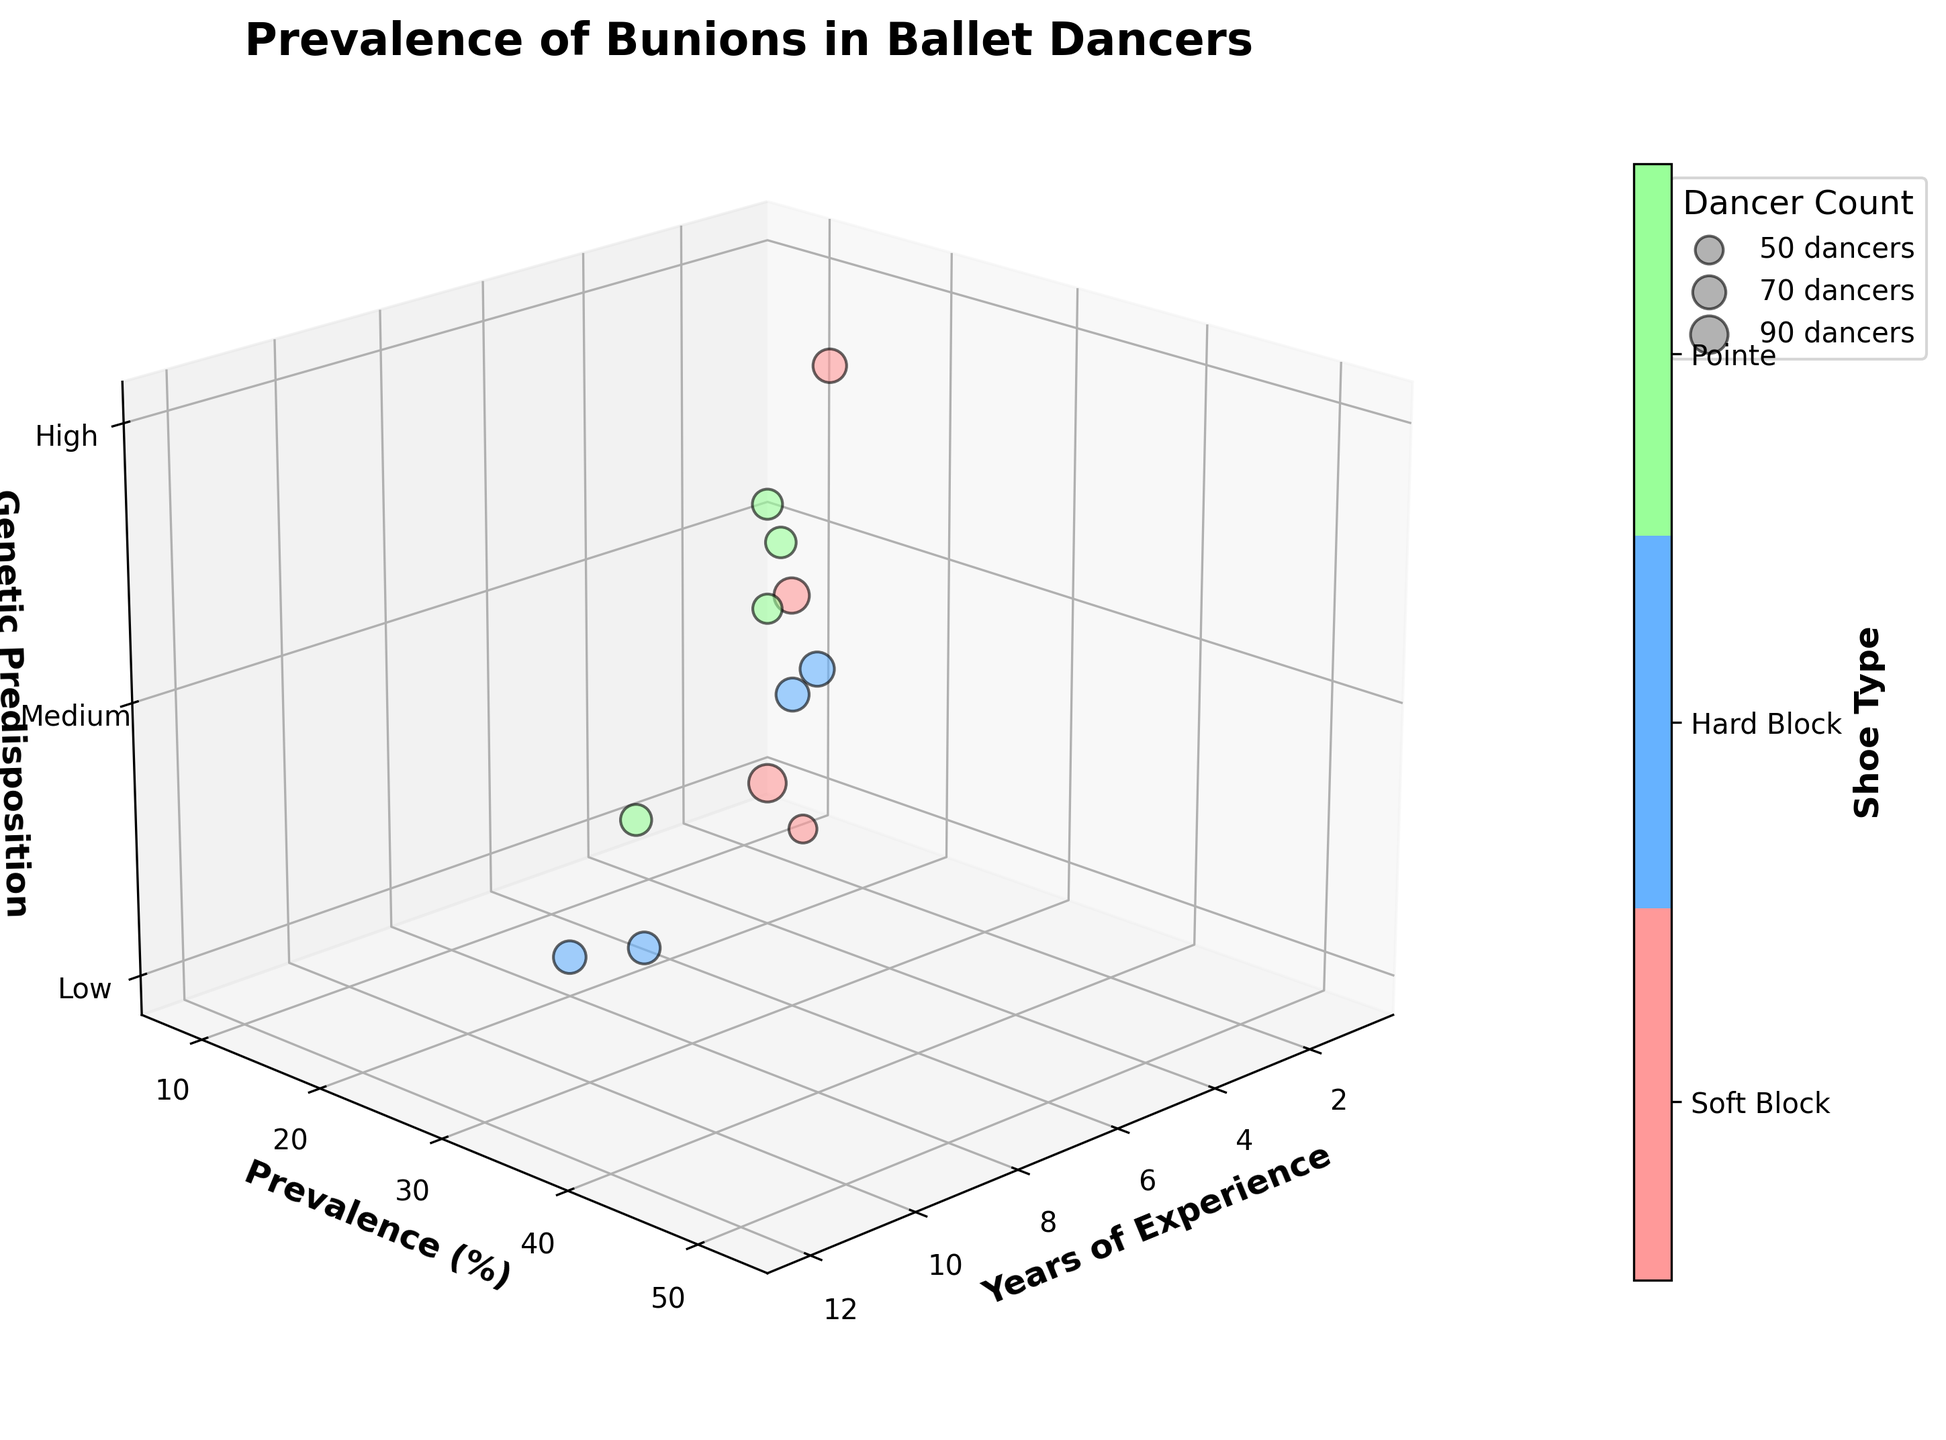What is the title of the chart? The title of the chart is typically located at the top of the figure. By looking there, we can see the title given for this chart.
Answer: Prevalence of Bunions in Ballet Dancers What is the prevalence of bunions for dancers with 5 years of experience using Hard Block shoes? Locate the data point where the years of experience is 5 and the Shoe Type is indicated by the color associated with Hard Block shoes. The y-axis will provide the prevalence percentage.
Answer: 28% For dancers with 10 years of experience, which genetic predisposition level has the highest prevalence? For 10 years of experience, check the z-axis values corresponding to the given experience. The highest tick level of 3 indicates 'High' genetic predisposition.
Answer: High Which shoe type is represented by the color green? From the color bar legend, we identify that the color green corresponds to one of the shoe types. The green color is associated with Pointe shoes.
Answer: Pointe How does the prevalence of bunions compare between dancers with 7 years of experience versus 8 years of experience? Compare the y-axis values for points where the years of experience are 7 and 8.
Answer: 22% for 7 years, 20% for 8 years Which genetic predisposition level sees the highest prevalence of bunions overall? Observing the z-axis across all data points, identify the genetic predisposition level with the highest prevalence (y-axis). Predominantly, the highest prevalence is noted at the 'High' level (3).
Answer: High Among dancers using Soft Block shoes, who has the lowest dancer count, and what is their prevalence? Identify the color representing Soft Block shoes, then find the smallest bubble (size indicates dancer count) among these and note its prevalence from the y-axis.
Answer: 8% for 1 year of experience What is the average prevalence of bunions across all dancers using Pointe shoes? Locate all data points representing Pointe shoes, sum their prevalence, and divide by the number of these data points (three values: 45, 52, 40). Calculation: (45 + 52 + 40) / 3 = 137 / 3 = 45.7
Answer: 45.7% Is there a trend between years of experience and the prevalence of bunions among ballet dancers? Examine the chart to determine if there's a visual trend or pattern in the data points along the x (years of experience) and y-axis (prevalence). As experience increases, an increasing trend in prevalence is observable.
Answer: Prevalence increases with experience 